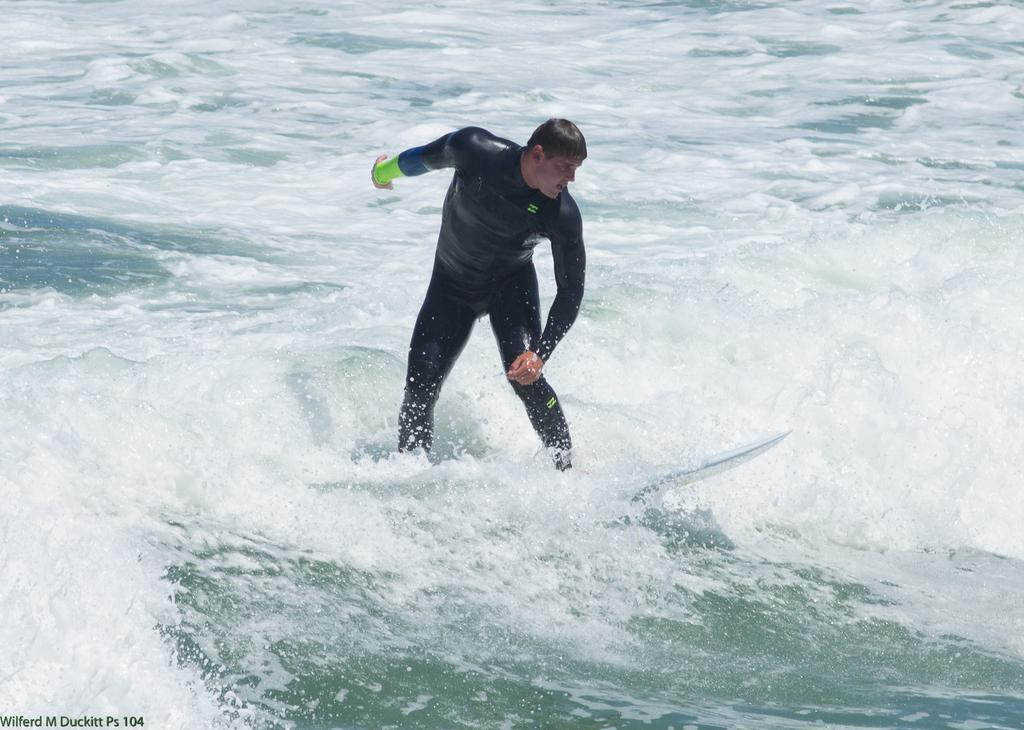What is the main subject of the image? There is a person in the image. What is the person doing in the image? The person is standing on a surfboard. Where is the surfboard located in the image? The surfboard is on the water. What is the person wearing in the image? The person is wearing a black dress. What type of beetle can be seen crawling in the alley in the image? There is no beetle or alley present in the image; it features a person standing on a surfboard on the water. Can you tell me how many sinks are visible in the image? There are no sinks present in the image. 